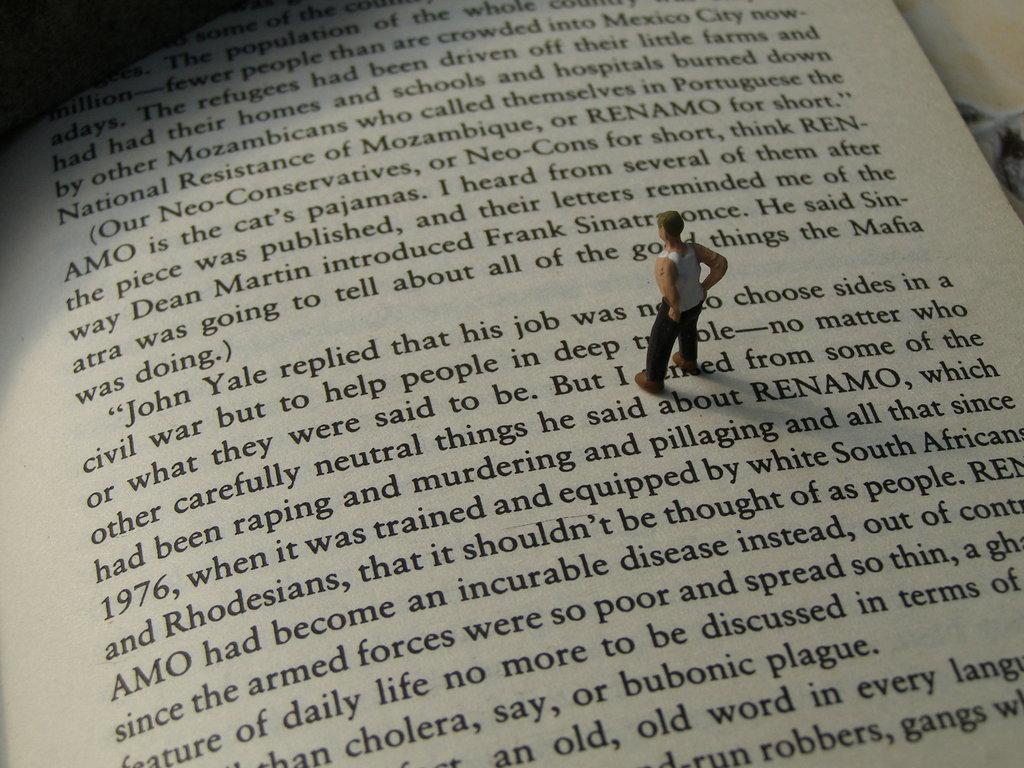<image>
Relay a brief, clear account of the picture shown. A toy figure stands in the middle of a page of a book on a paragraph beginning with the words "John Yale replied". 